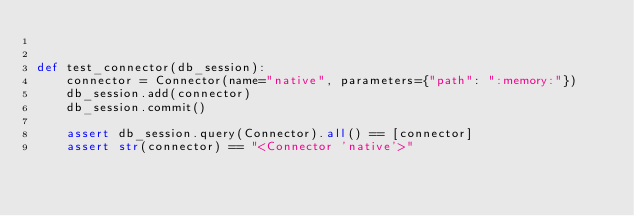<code> <loc_0><loc_0><loc_500><loc_500><_Python_>

def test_connector(db_session):
    connector = Connector(name="native", parameters={"path": ":memory:"})
    db_session.add(connector)
    db_session.commit()

    assert db_session.query(Connector).all() == [connector]
    assert str(connector) == "<Connector 'native'>"
</code> 